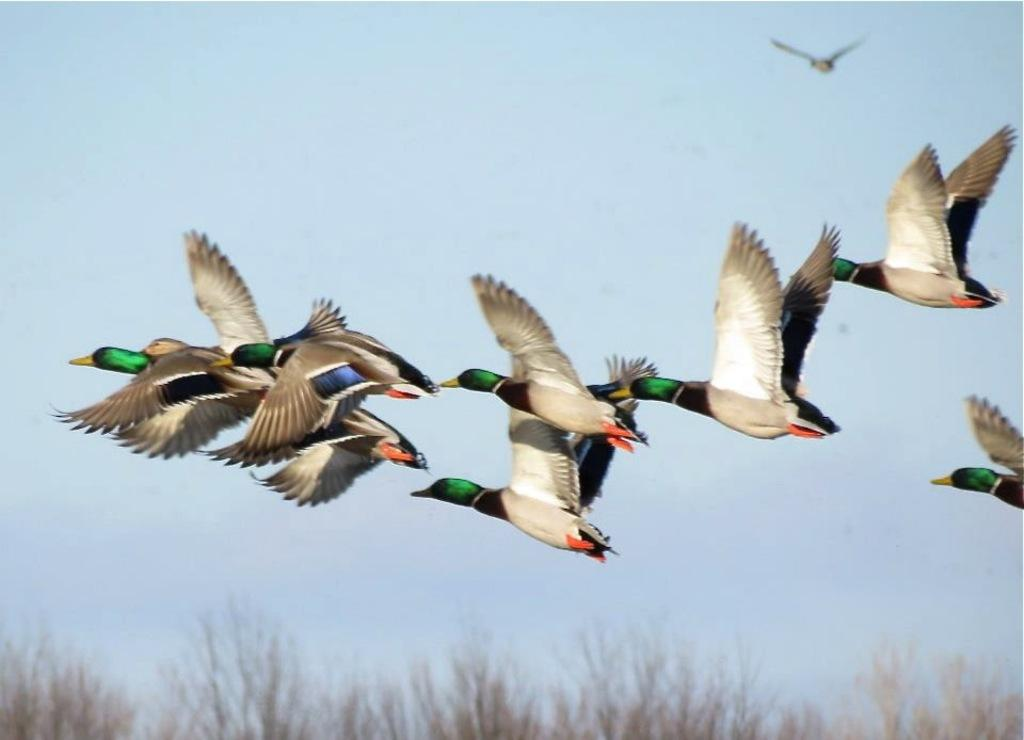What is happening in the sky in the image? There are birds flying in the sky in the image. What type of vegetation is at the bottom of the image? There is grass at the bottom of the image. What can be seen in the background of the image? The sky is visible in the background of the image. Where is the grandmother sitting with her crayons in the image? There is no grandmother or crayons present in the image. What type of planes can be seen flying in the sky in the image? There are no planes visible in the image; only birds are flying in the sky. 